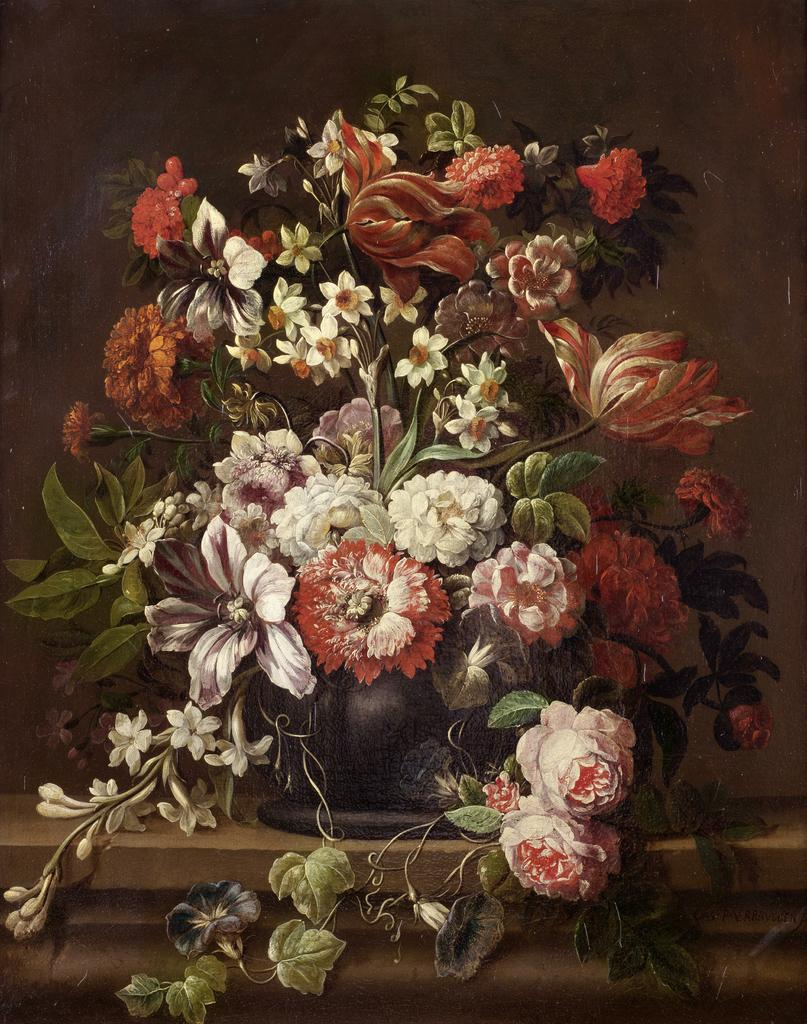What is the main object in the image? There is a flower vase in the image. What is inside the flower vase? The flower vase contains flowers of different colors. What can be observed about the flowers' appearance? The flowers have green leaves. Where is the flower vase located? The flower vase is on a wall. What is the color of the background in the image? The background of the image is dark in color. How much salt is present in the image? There is no salt present in the image; it features a flower vase with flowers and leaves. What grade is the flower vase in the image? The flower vase is not associated with a grade, as it is an object and not a student or educational assessment. 